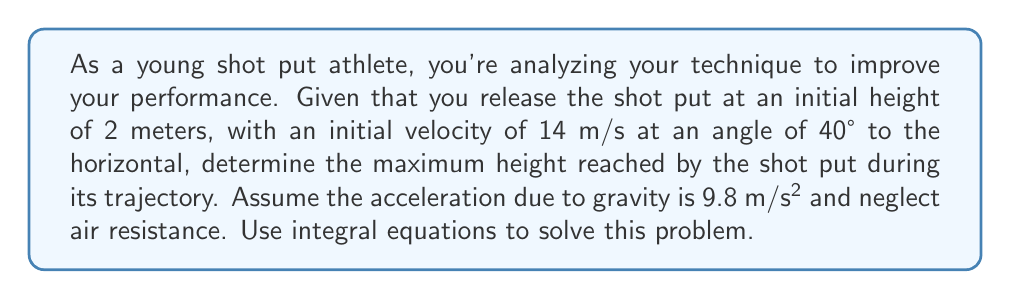Help me with this question. Let's approach this step-by-step using integral equations:

1) First, we need to break down the initial velocity into its horizontal and vertical components:
   $v_{x0} = 14 \cos(40°) \approx 10.73$ m/s
   $v_{y0} = 14 \sin(40°) \approx 8.99$ m/s

2) The horizontal velocity remains constant (neglecting air resistance), but the vertical velocity changes due to gravity. We can express the vertical velocity as a function of time:
   $v_y(t) = v_{y0} - gt$

3) To find the vertical position as a function of time, we need to integrate the velocity:
   $$y(t) = \int v_y(t) dt = \int (v_{y0} - gt) dt = v_{y0}t - \frac{1}{2}gt^2 + C$$

4) We know the initial height is 2 meters, so we can solve for C:
   At $t=0$, $y(0) = 2 = C$
   Therefore, $y(t) = 2 + v_{y0}t - \frac{1}{2}gt^2$

5) The maximum height is reached when the vertical velocity is zero. We can find this time by solving:
   $0 = v_y(t) = v_{y0} - gt$
   $t = \frac{v_{y0}}{g} \approx \frac{8.99}{9.8} \approx 0.92$ seconds

6) Now we can substitute this time back into our position equation to find the maximum height:
   $$y_{max} = 2 + 8.99(0.92) - \frac{1}{2}(9.8)(0.92)^2 \approx 6.06$$ meters

Therefore, the maximum height reached by the shot put is approximately 6.06 meters.
Answer: 6.06 meters 